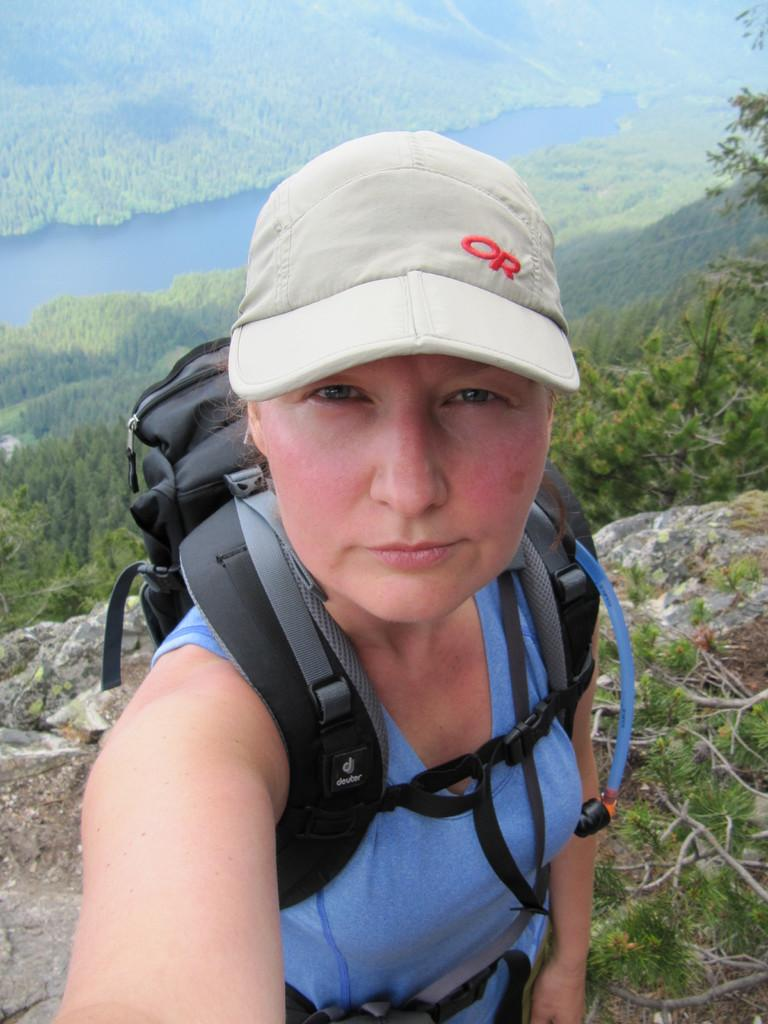Who is the main subject in the image? There is a woman in the image. What is the woman wearing on her upper body? The woman is wearing a blue t-shirt. What is the woman wearing on her head? The woman is wearing a grey cap. Where is the woman located in the image? The woman is standing on top of a hill. What is the woman carrying on her back? The woman is carrying a backpack. What can be seen in the background of the image? There are trees and a river visible in the background of the image. How many clocks are hanging on the trees in the background of the image? There are no clocks visible in the image; only trees and a river can be seen in the background. 